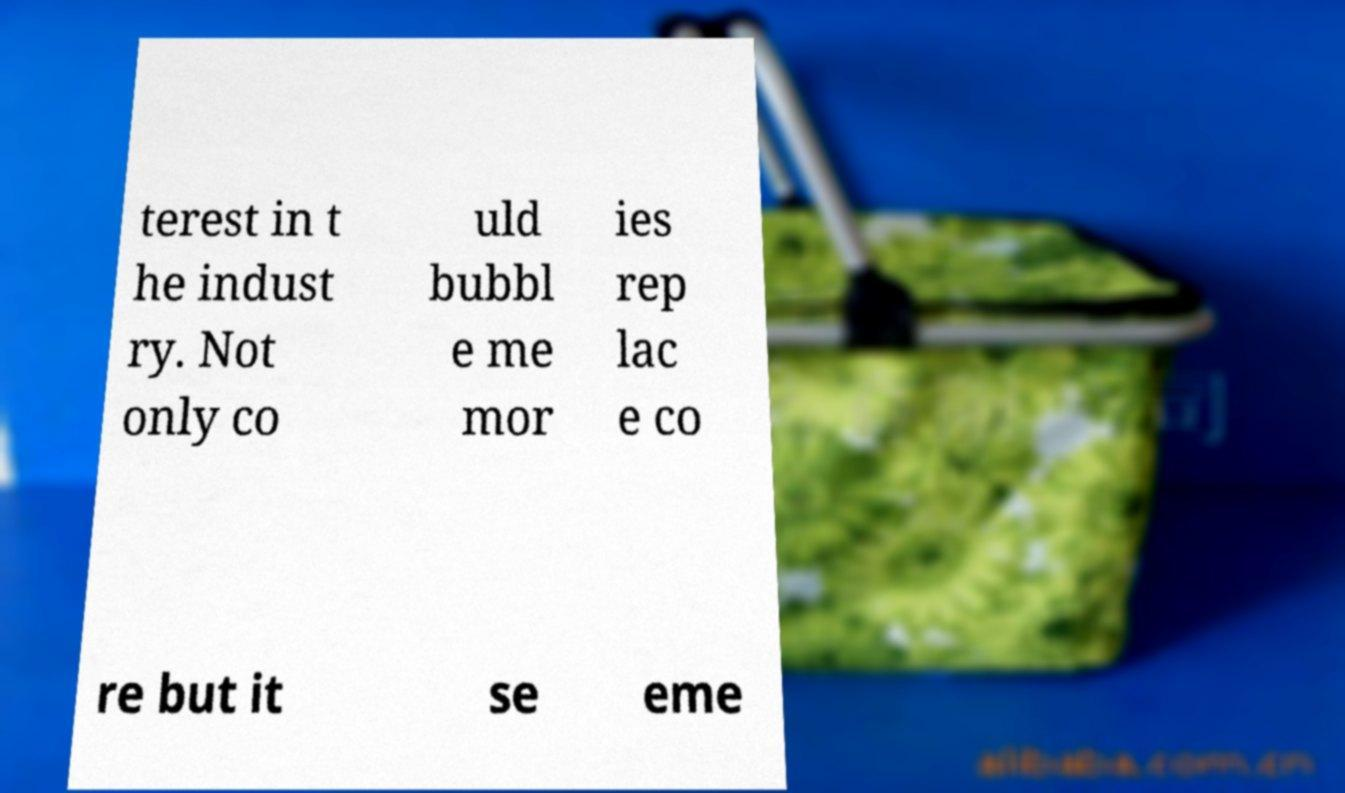Please read and relay the text visible in this image. What does it say? terest in t he indust ry. Not only co uld bubbl e me mor ies rep lac e co re but it se eme 